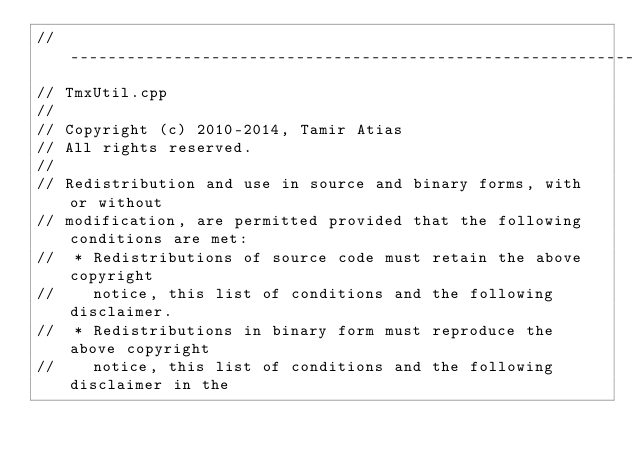Convert code to text. <code><loc_0><loc_0><loc_500><loc_500><_C++_>//-----------------------------------------------------------------------------
// TmxUtil.cpp
//
// Copyright (c) 2010-2014, Tamir Atias
// All rights reserved.
//
// Redistribution and use in source and binary forms, with or without
// modification, are permitted provided that the following conditions are met:
//  * Redistributions of source code must retain the above copyright
//    notice, this list of conditions and the following disclaimer.
//  * Redistributions in binary form must reproduce the above copyright
//    notice, this list of conditions and the following disclaimer in the</code> 